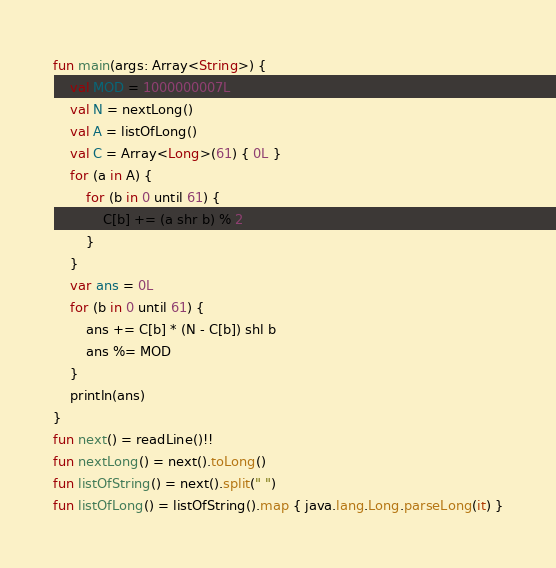<code> <loc_0><loc_0><loc_500><loc_500><_Kotlin_>fun main(args: Array<String>) {
    val MOD = 1000000007L
    val N = nextLong()
    val A = listOfLong()
    val C = Array<Long>(61) { 0L }
    for (a in A) {
        for (b in 0 until 61) {
            C[b] += (a shr b) % 2
        }
    }
    var ans = 0L
    for (b in 0 until 61) {
        ans += C[b] * (N - C[b]) shl b
        ans %= MOD
    }
    println(ans)
}
fun next() = readLine()!!
fun nextLong() = next().toLong()
fun listOfString() = next().split(" ")
fun listOfLong() = listOfString().map { java.lang.Long.parseLong(it) }</code> 